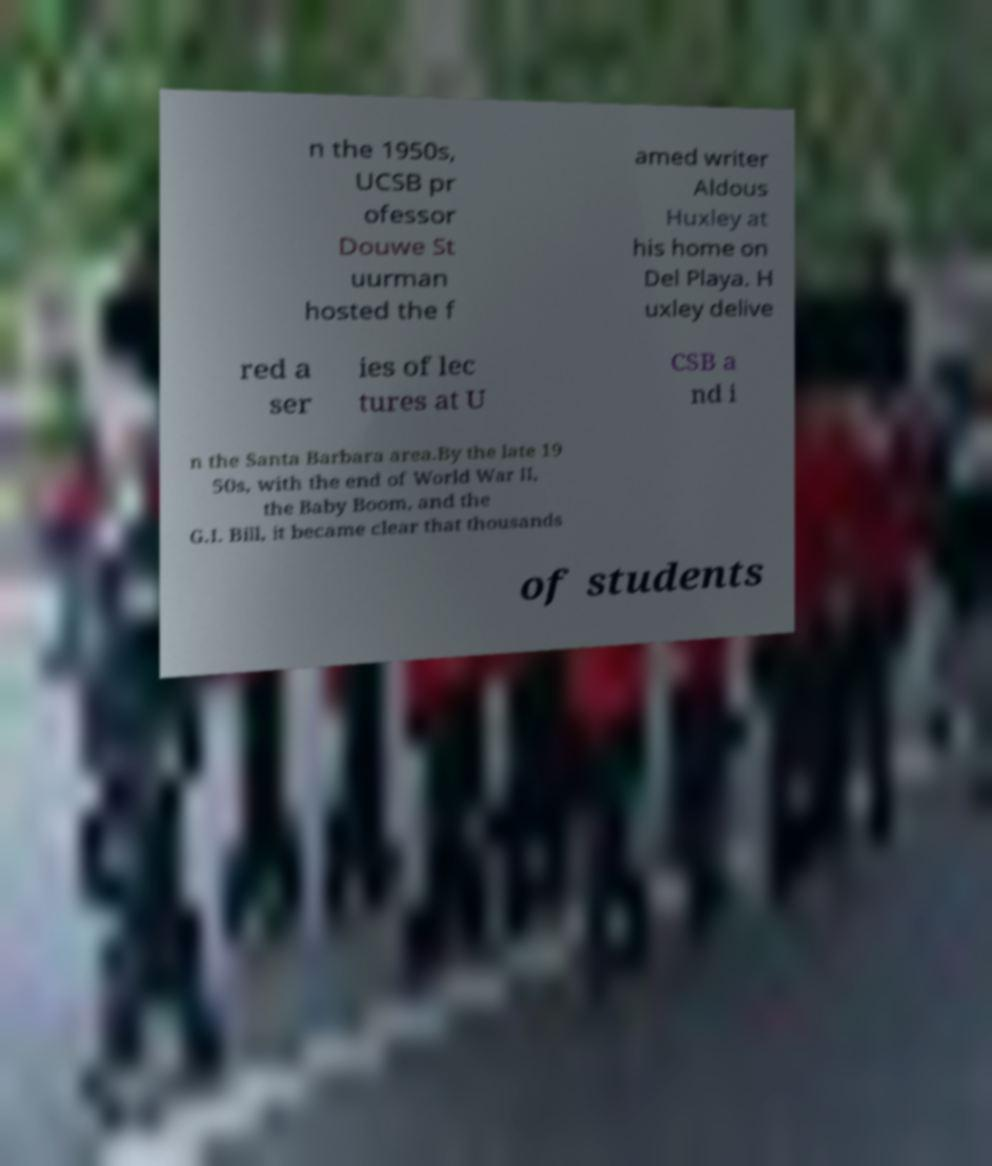For documentation purposes, I need the text within this image transcribed. Could you provide that? n the 1950s, UCSB pr ofessor Douwe St uurman hosted the f amed writer Aldous Huxley at his home on Del Playa. H uxley delive red a ser ies of lec tures at U CSB a nd i n the Santa Barbara area.By the late 19 50s, with the end of World War II, the Baby Boom, and the G.I. Bill, it became clear that thousands of students 